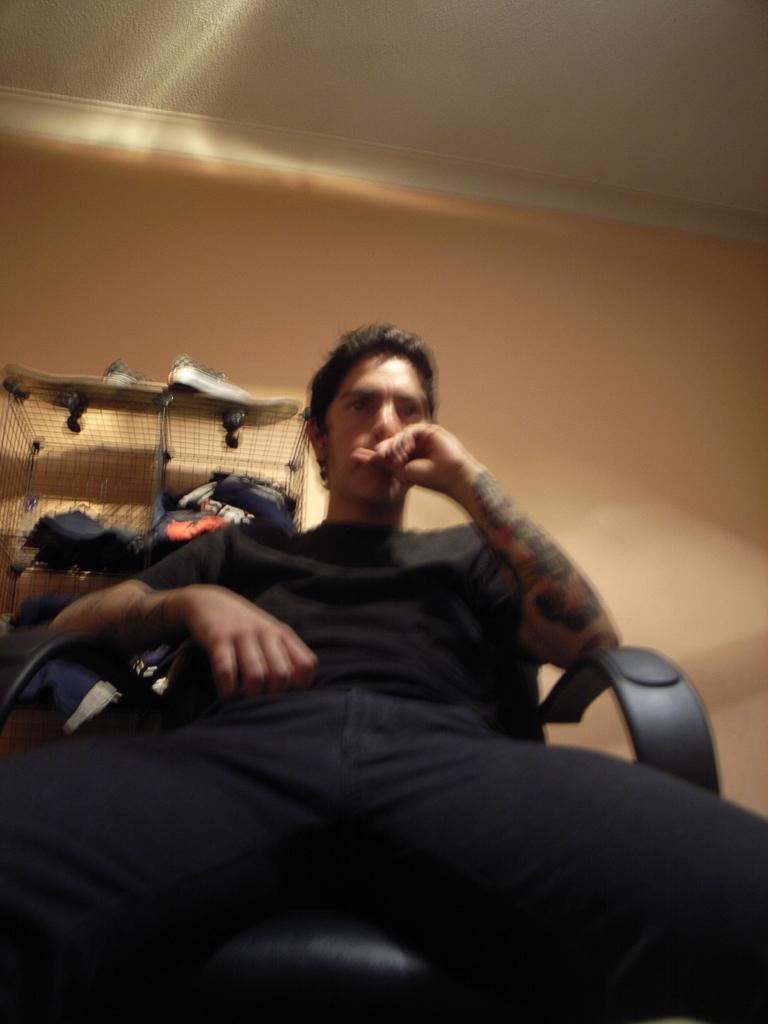Who is present in the image? There is a man in the image. What is the man doing in the image? The man is sitting on a chair in the image. What can be seen in the background of the image? There is a wall in the background of the image. What is the man's temper like in the image? There is no information about the man's temper in the image. 